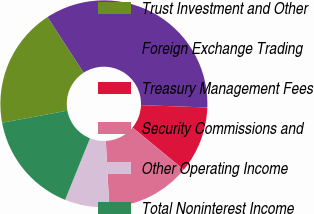Convert chart. <chart><loc_0><loc_0><loc_500><loc_500><pie_chart><fcel>Trust Investment and Other<fcel>Foreign Exchange Trading<fcel>Treasury Management Fees<fcel>Security Commissions and<fcel>Other Operating Income<fcel>Total Noninterest Income<nl><fcel>18.75%<fcel>34.72%<fcel>10.42%<fcel>13.19%<fcel>6.94%<fcel>15.97%<nl></chart> 